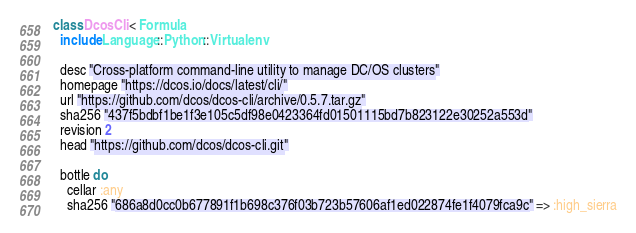<code> <loc_0><loc_0><loc_500><loc_500><_Ruby_>class DcosCli < Formula
  include Language::Python::Virtualenv

  desc "Cross-platform command-line utility to manage DC/OS clusters"
  homepage "https://dcos.io/docs/latest/cli/"
  url "https://github.com/dcos/dcos-cli/archive/0.5.7.tar.gz"
  sha256 "437f5bdbf1be1f3e105c5df98e0423364fd01501115bd7b823122e30252a553d"
  revision 2
  head "https://github.com/dcos/dcos-cli.git"

  bottle do
    cellar :any
    sha256 "686a8d0cc0b677891f1b698c376f03b723b57606af1ed022874fe1f4079fca9c" => :high_sierra</code> 